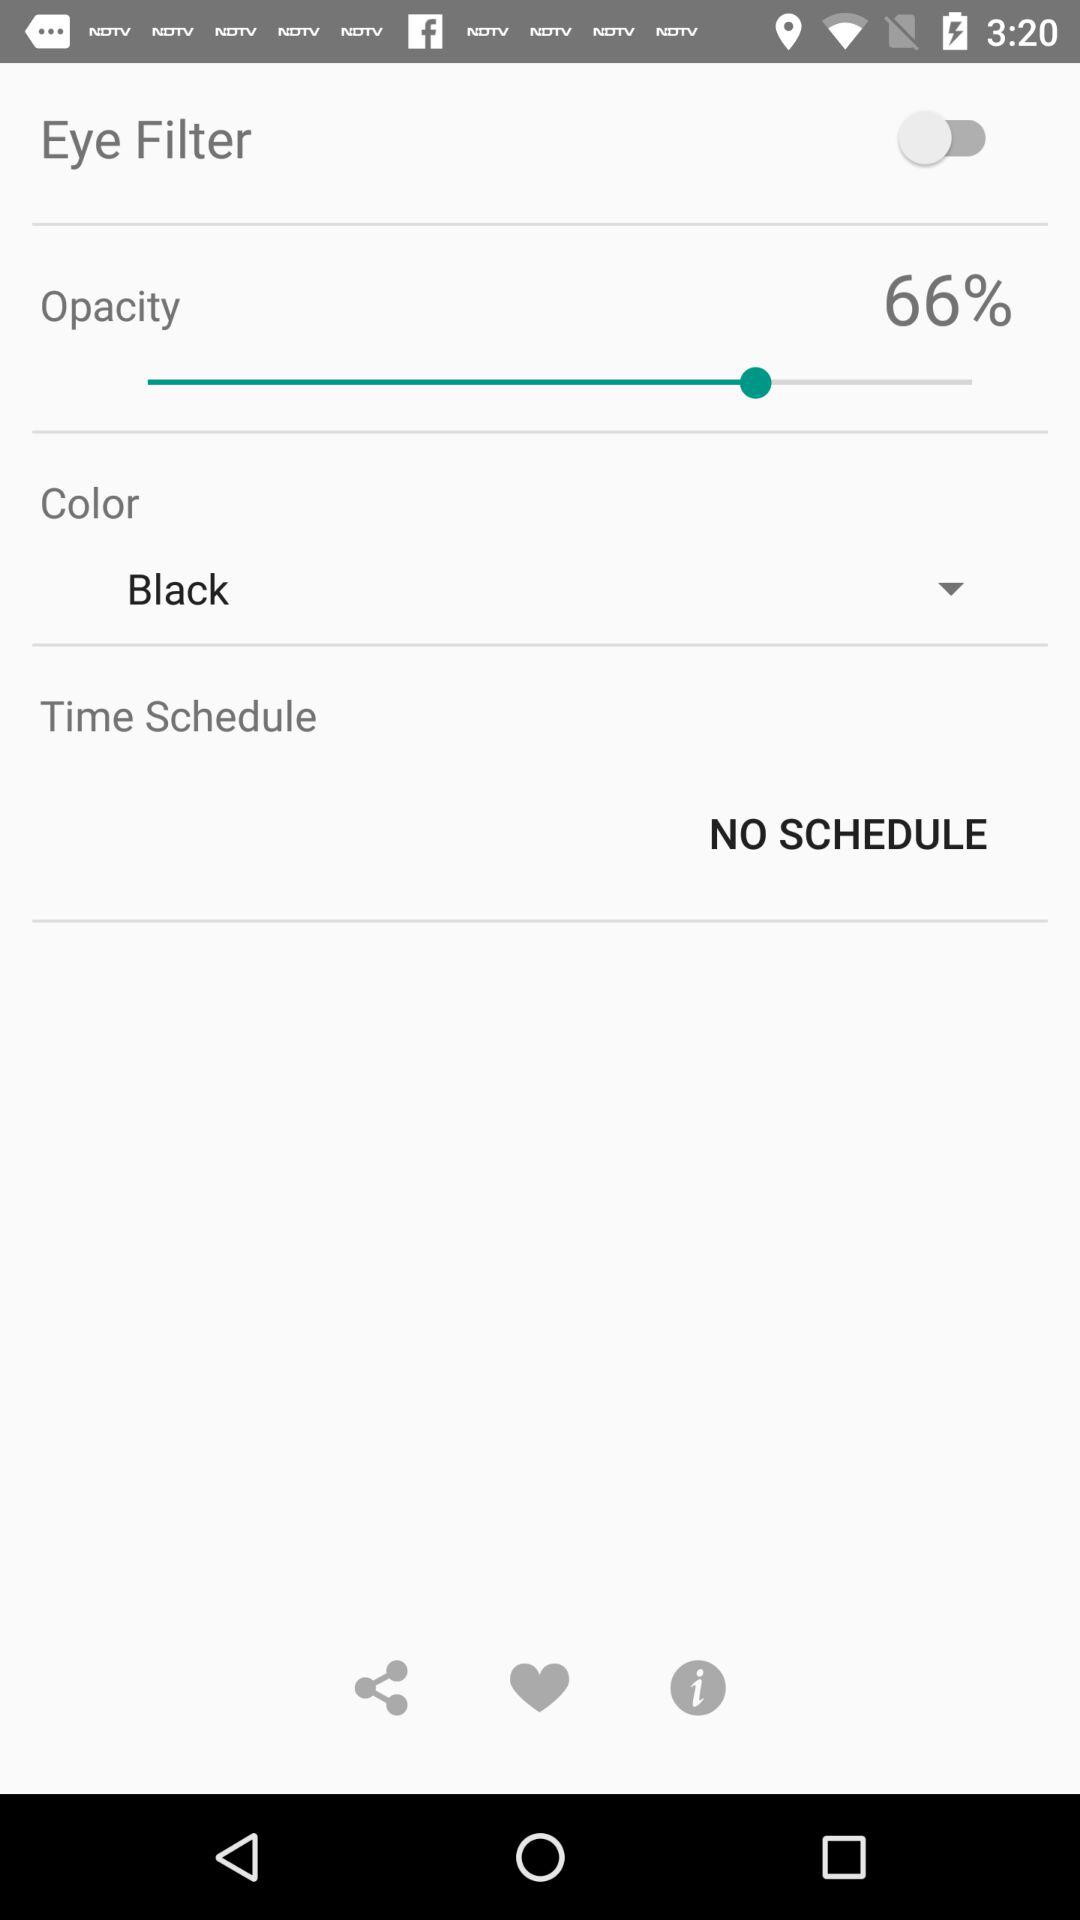What is the scheduled time? There is no scheduled time. 